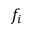Convert formula to latex. <formula><loc_0><loc_0><loc_500><loc_500>f _ { i }</formula> 